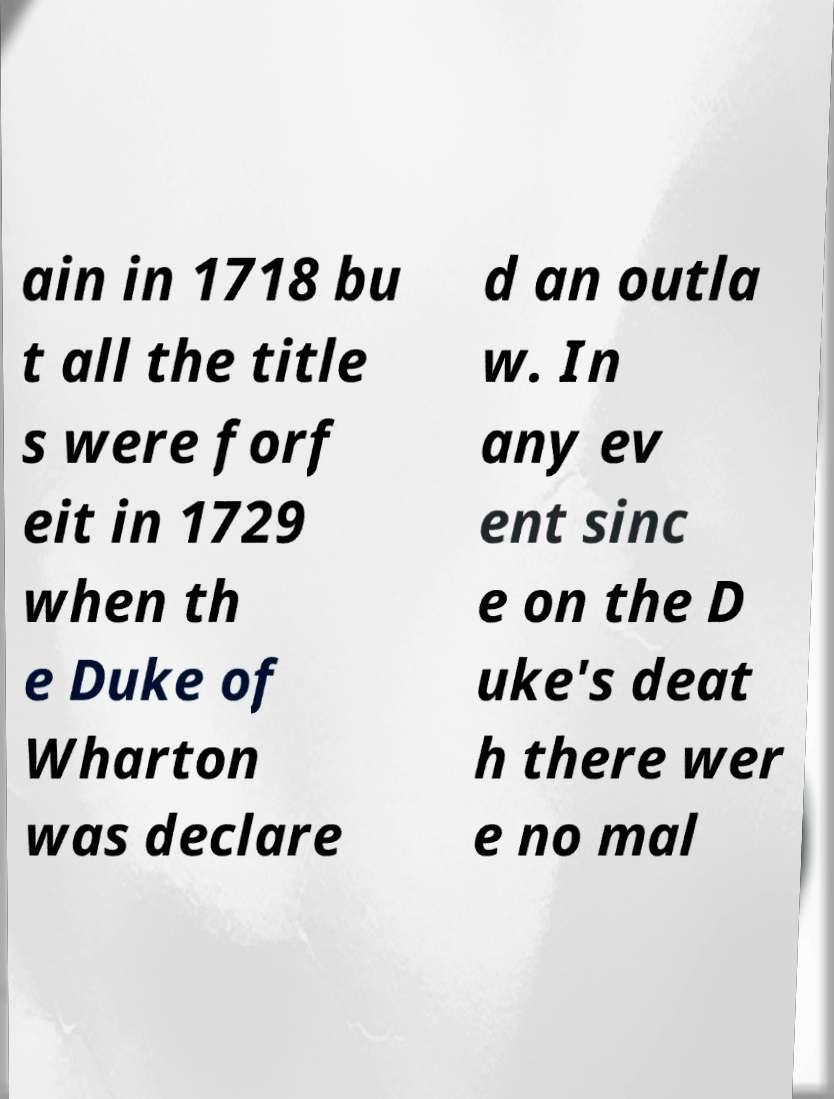For documentation purposes, I need the text within this image transcribed. Could you provide that? ain in 1718 bu t all the title s were forf eit in 1729 when th e Duke of Wharton was declare d an outla w. In any ev ent sinc e on the D uke's deat h there wer e no mal 